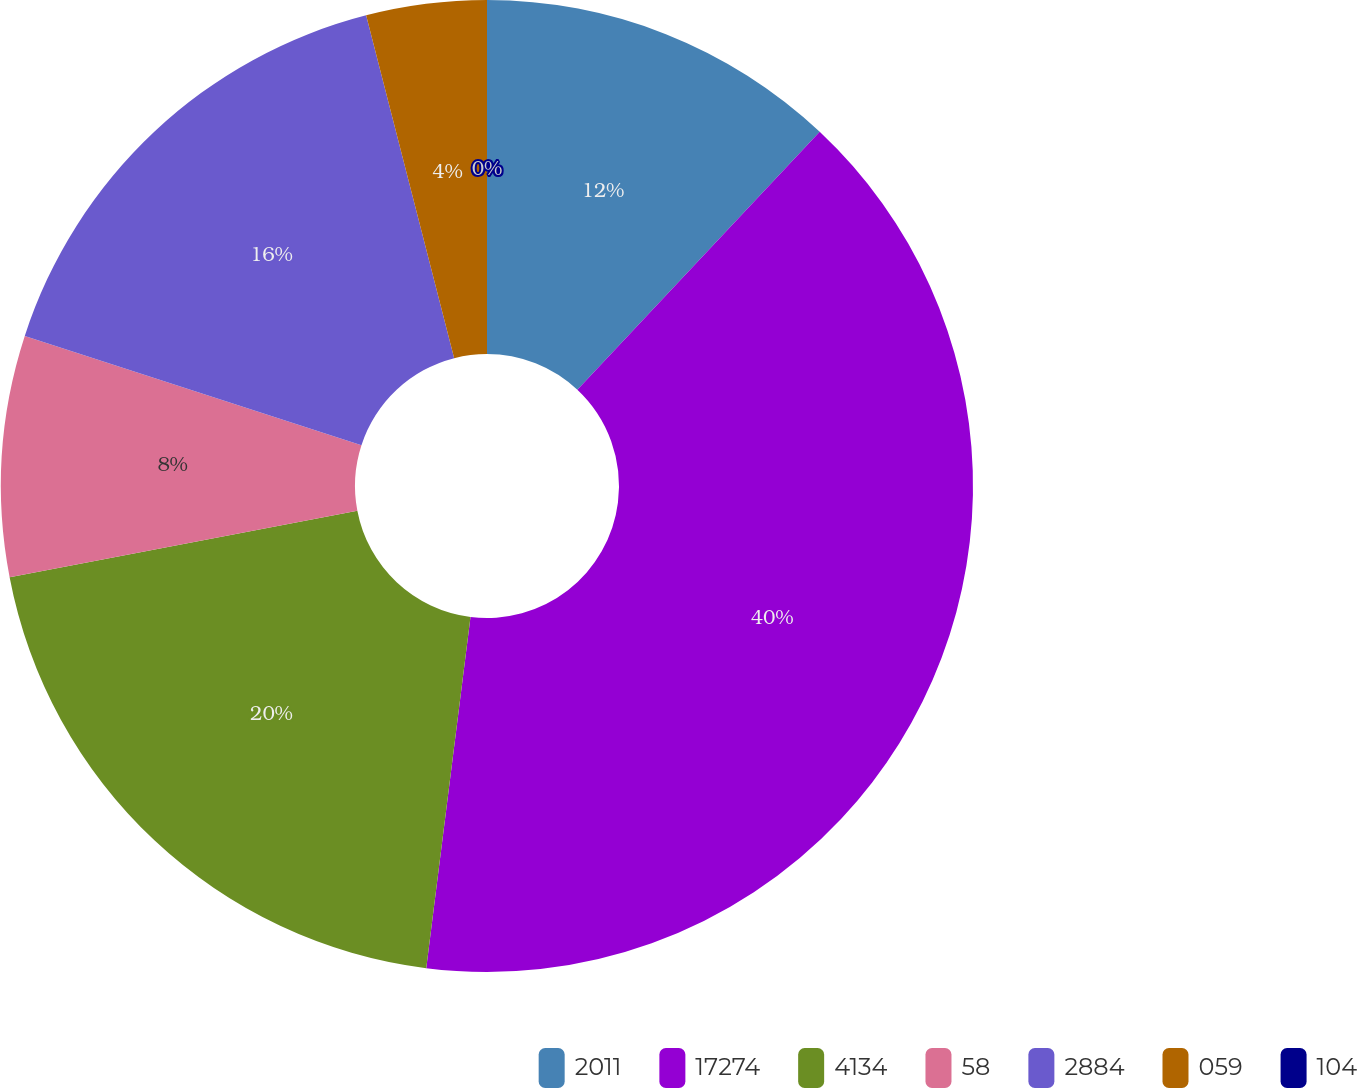<chart> <loc_0><loc_0><loc_500><loc_500><pie_chart><fcel>2011<fcel>17274<fcel>4134<fcel>58<fcel>2884<fcel>059<fcel>104<nl><fcel>12.0%<fcel>39.99%<fcel>20.0%<fcel>8.0%<fcel>16.0%<fcel>4.0%<fcel>0.0%<nl></chart> 